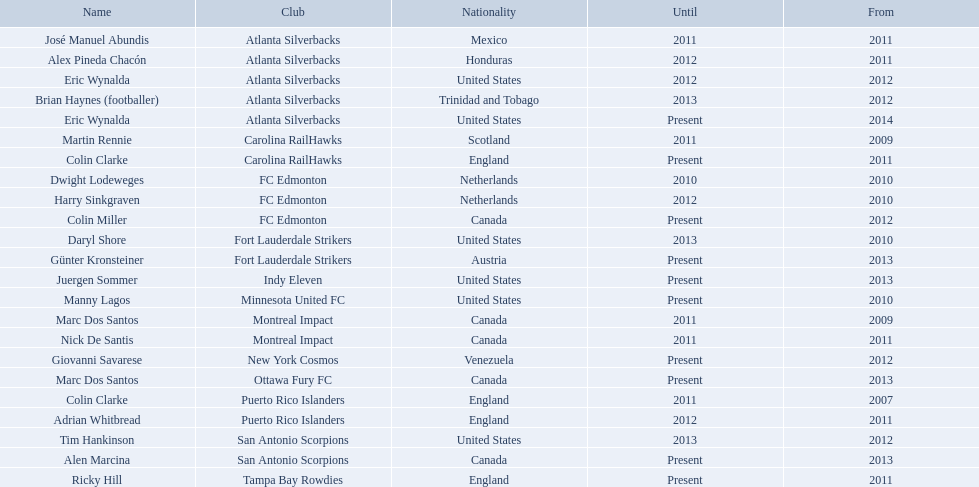Give me the full table as a dictionary. {'header': ['Name', 'Club', 'Nationality', 'Until', 'From'], 'rows': [['José Manuel Abundis', 'Atlanta Silverbacks', 'Mexico', '2011', '2011'], ['Alex Pineda Chacón', 'Atlanta Silverbacks', 'Honduras', '2012', '2011'], ['Eric Wynalda', 'Atlanta Silverbacks', 'United States', '2012', '2012'], ['Brian Haynes (footballer)', 'Atlanta Silverbacks', 'Trinidad and Tobago', '2013', '2012'], ['Eric Wynalda', 'Atlanta Silverbacks', 'United States', 'Present', '2014'], ['Martin Rennie', 'Carolina RailHawks', 'Scotland', '2011', '2009'], ['Colin Clarke', 'Carolina RailHawks', 'England', 'Present', '2011'], ['Dwight Lodeweges', 'FC Edmonton', 'Netherlands', '2010', '2010'], ['Harry Sinkgraven', 'FC Edmonton', 'Netherlands', '2012', '2010'], ['Colin Miller', 'FC Edmonton', 'Canada', 'Present', '2012'], ['Daryl Shore', 'Fort Lauderdale Strikers', 'United States', '2013', '2010'], ['Günter Kronsteiner', 'Fort Lauderdale Strikers', 'Austria', 'Present', '2013'], ['Juergen Sommer', 'Indy Eleven', 'United States', 'Present', '2013'], ['Manny Lagos', 'Minnesota United FC', 'United States', 'Present', '2010'], ['Marc Dos Santos', 'Montreal Impact', 'Canada', '2011', '2009'], ['Nick De Santis', 'Montreal Impact', 'Canada', '2011', '2011'], ['Giovanni Savarese', 'New York Cosmos', 'Venezuela', 'Present', '2012'], ['Marc Dos Santos', 'Ottawa Fury FC', 'Canada', 'Present', '2013'], ['Colin Clarke', 'Puerto Rico Islanders', 'England', '2011', '2007'], ['Adrian Whitbread', 'Puerto Rico Islanders', 'England', '2012', '2011'], ['Tim Hankinson', 'San Antonio Scorpions', 'United States', '2013', '2012'], ['Alen Marcina', 'San Antonio Scorpions', 'Canada', 'Present', '2013'], ['Ricky Hill', 'Tampa Bay Rowdies', 'England', 'Present', '2011']]} What year did marc dos santos start as coach? 2009. Which other starting years correspond with this year? 2009. Who was the other coach with this starting year Martin Rennie. 